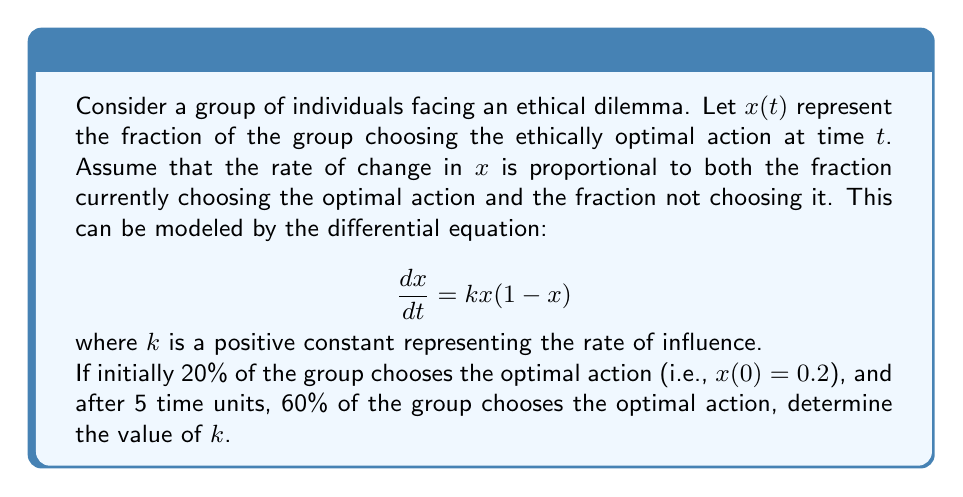Show me your answer to this math problem. To solve this problem, we'll follow these steps:

1) First, we need to solve the given differential equation. This is a separable equation of the form:

   $$\frac{dx}{dt} = kx(1-x)$$

2) Separating the variables:

   $$\frac{dx}{x(1-x)} = k dt$$

3) Integrating both sides:

   $$\int \frac{dx}{x(1-x)} = \int k dt$$

4) The left side can be integrated using partial fractions:

   $$\ln|\frac{x}{1-x}| = kt + C$$

5) Solving for $x$:

   $$\frac{x}{1-x} = Ce^{kt}$$
   $$x = \frac{Ce^{kt}}{1+Ce^{kt}}$$

6) Now, we can use the initial condition $x(0) = 0.2$ to find $C$:

   $$0.2 = \frac{C}{1+C}$$
   $$C = \frac{1}{4}$$

7) So our particular solution is:

   $$x(t) = \frac{(1/4)e^{kt}}{1+(1/4)e^{kt}}$$

8) Now, we can use the condition that $x(5) = 0.6$:

   $$0.6 = \frac{(1/4)e^{5k}}{1+(1/4)e^{5k}}$$

9) Solving this equation for $k$:

   $$0.6(1+(1/4)e^{5k}) = (1/4)e^{5k}$$
   $$0.6 + 0.15e^{5k} = 0.25e^{5k}$$
   $$0.6 = 0.1e^{5k}$$
   $$6 = e^{5k}$$
   $$\ln(6) = 5k$$
   $$k = \frac{\ln(6)}{5} \approx 0.3577$$

Therefore, the value of $k$ is approximately 0.3577.
Answer: $k = \frac{\ln(6)}{5} \approx 0.3577$ 